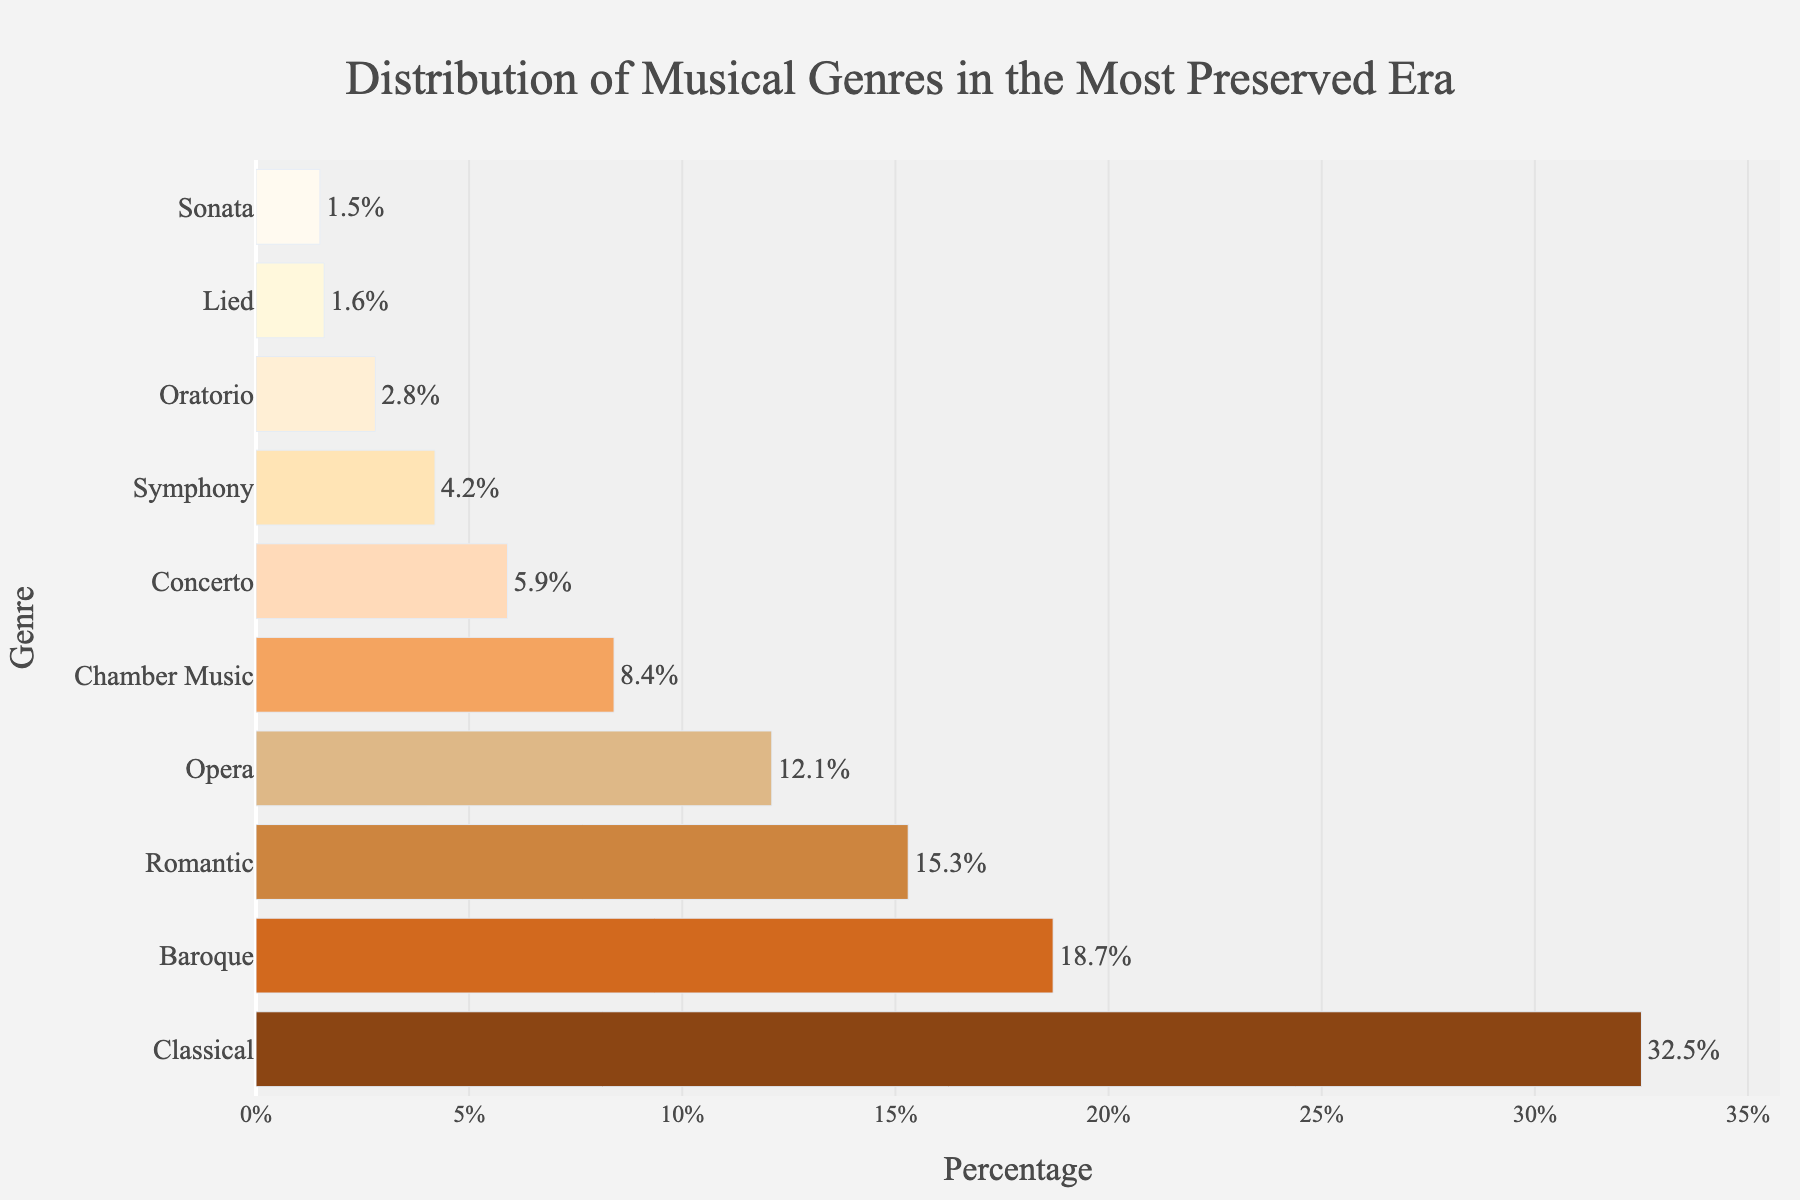Which genre has the highest percentage? The bar representing Classical is the longest and has the highest value of 32.5%.
Answer: Classical Which genre has a higher percentage, Baroque or Romantic? The bar for Baroque is longer than the bar for Romantic, with values of 18.7% and 15.3% respectively.
Answer: Baroque How much larger is the percentage of Classical music compared to Chamber Music? The percentage of Classical is 32.5%, and Chamber Music is 8.4%. The difference is 32.5% - 8.4%.
Answer: 24.1% What is the combined percentage of Opera and Concerto? The percentage of Opera is 12.1%, and Concerto is 5.9%. Their combined percentage is 12.1% + 5.9%.
Answer: 18% Which genre has the smallest percentage? The bar representing Sonata is the shortest with a value of 1.5%.
Answer: Sonata Which genre has a greater percentage, Symphony or Lied? The bar for Symphony is longer than the bar for Lied, with values of 4.2% and 1.6% respectively.
Answer: Symphony What is the average percentage of Symphony and Oratorio? The percentage of Symphony is 4.2%, and Oratorio is 2.8%. The average is (4.2% + 2.8%) / 2.
Answer: 3.5% What is the combined percentage of the top three genres? The top three genres are Classical (32.5%), Baroque (18.7%), and Romantic (15.3%). Their combined percentage is 32.5% + 18.7% + 15.3%.
Answer: 66.5% Which genre has almost half the percentage of Baroque? The percentage of Baroque is 18.7%, and Opera is close to half of that percentage, at 12.1%.
Answer: Opera 